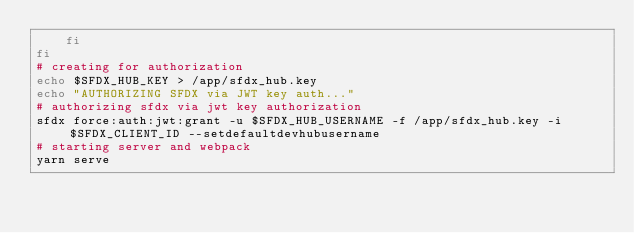<code> <loc_0><loc_0><loc_500><loc_500><_Bash_>    fi
fi
# creating for authorization
echo $SFDX_HUB_KEY > /app/sfdx_hub.key
echo "AUTHORIZING SFDX via JWT key auth..."
# authorizing sfdx via jwt key authorization
sfdx force:auth:jwt:grant -u $SFDX_HUB_USERNAME -f /app/sfdx_hub.key -i $SFDX_CLIENT_ID --setdefaultdevhubusername
# starting server and webpack
yarn serve
</code> 